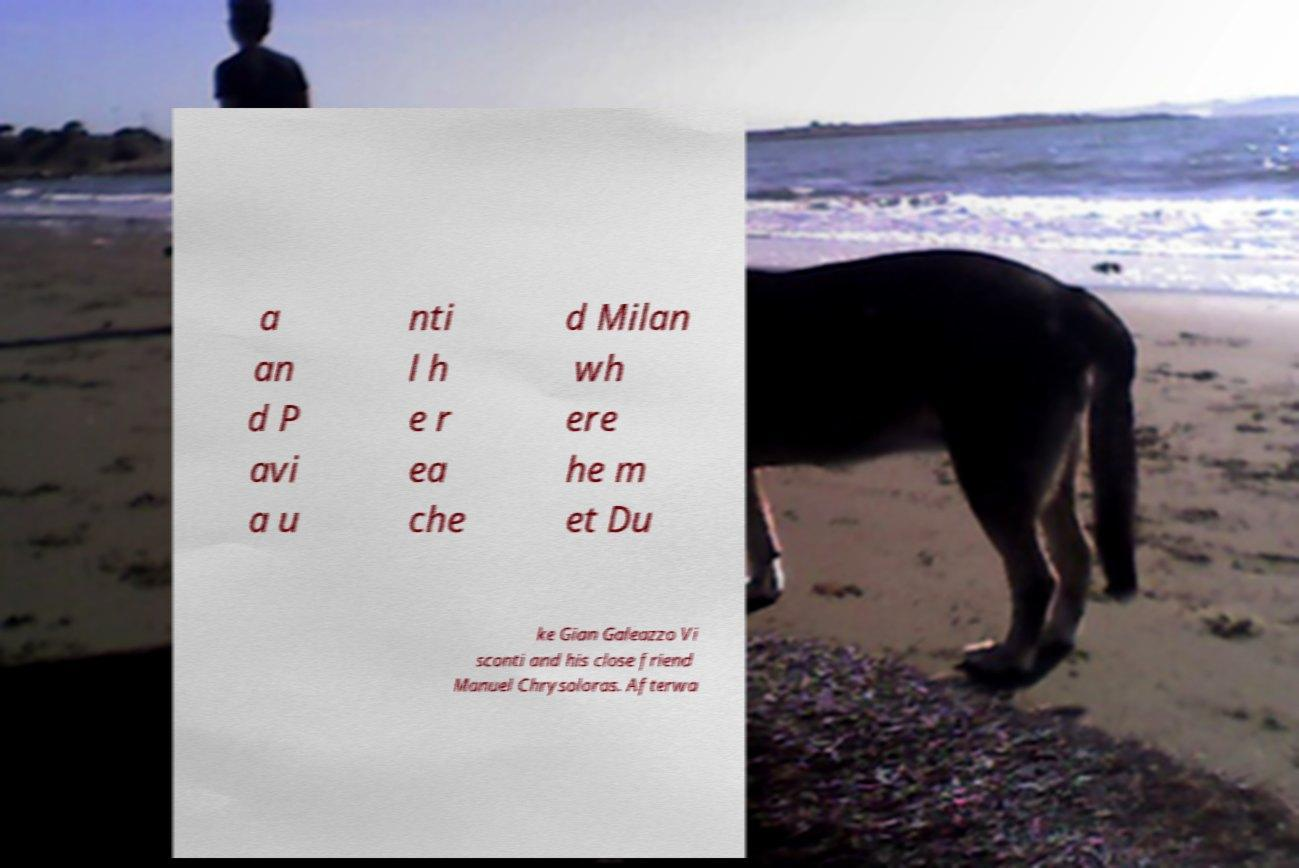Could you extract and type out the text from this image? a an d P avi a u nti l h e r ea che d Milan wh ere he m et Du ke Gian Galeazzo Vi sconti and his close friend Manuel Chrysoloras. Afterwa 